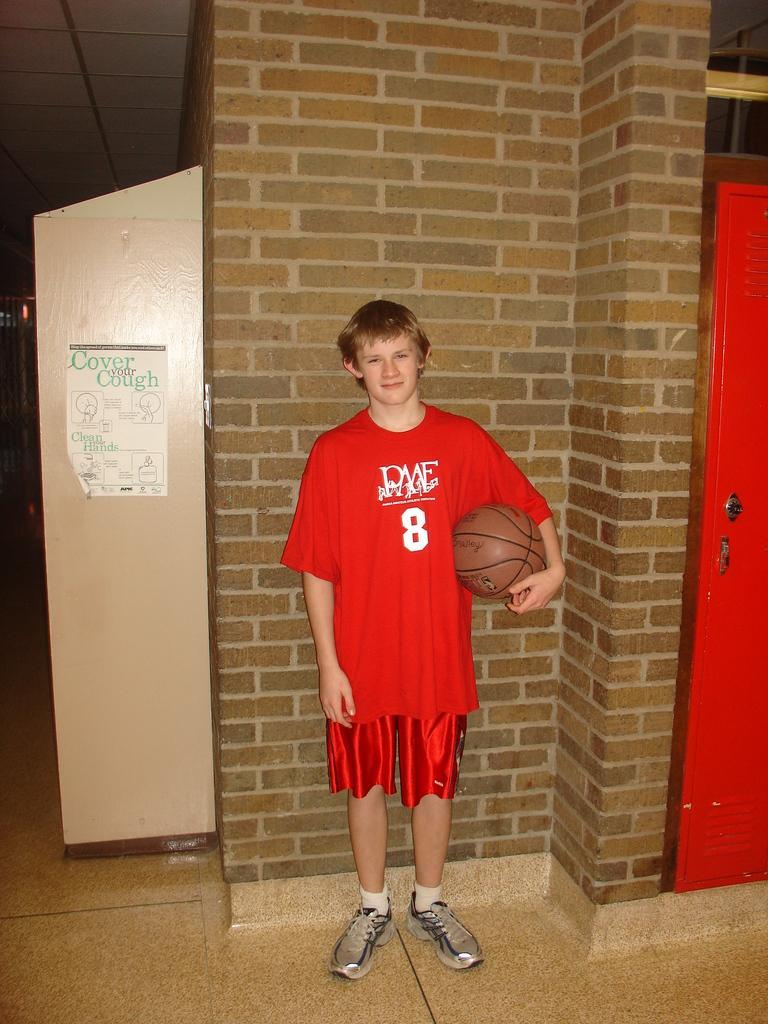Provide a one-sentence caption for the provided image. A possible teenager standing against the wall wearing a basketball jersey with the number 8 on it. 